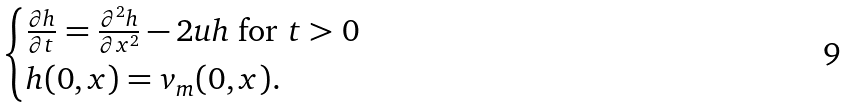Convert formula to latex. <formula><loc_0><loc_0><loc_500><loc_500>\begin{cases} \frac { \partial h } { \partial t } = \frac { \partial ^ { 2 } h } { \partial x ^ { 2 } } - 2 u h \text { for } t > 0 \\ h ( 0 , x ) = v _ { m } ( 0 , x ) . \end{cases}</formula> 